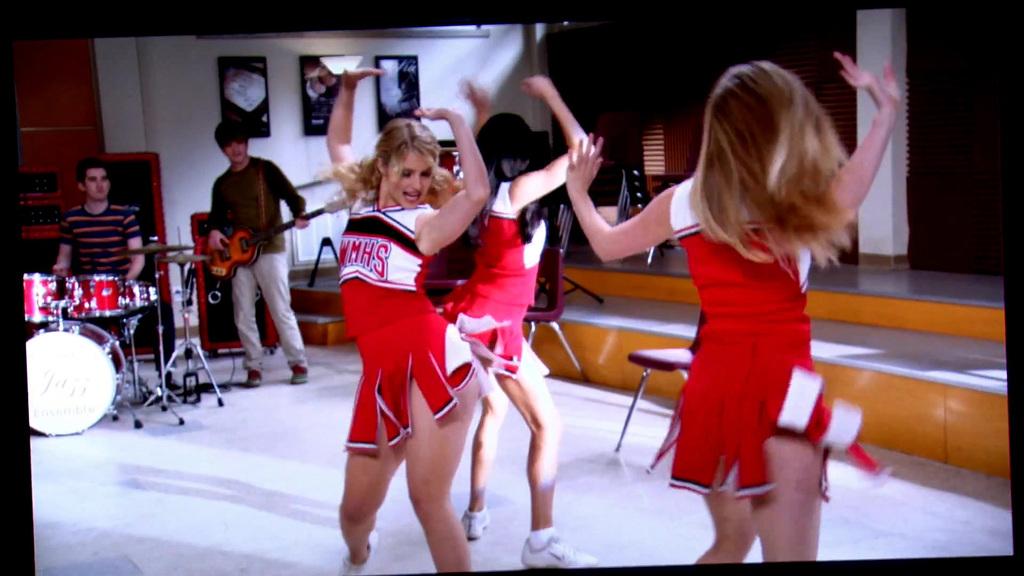What school does this cheer team cheer for?
Provide a succinct answer. Wmhs. 